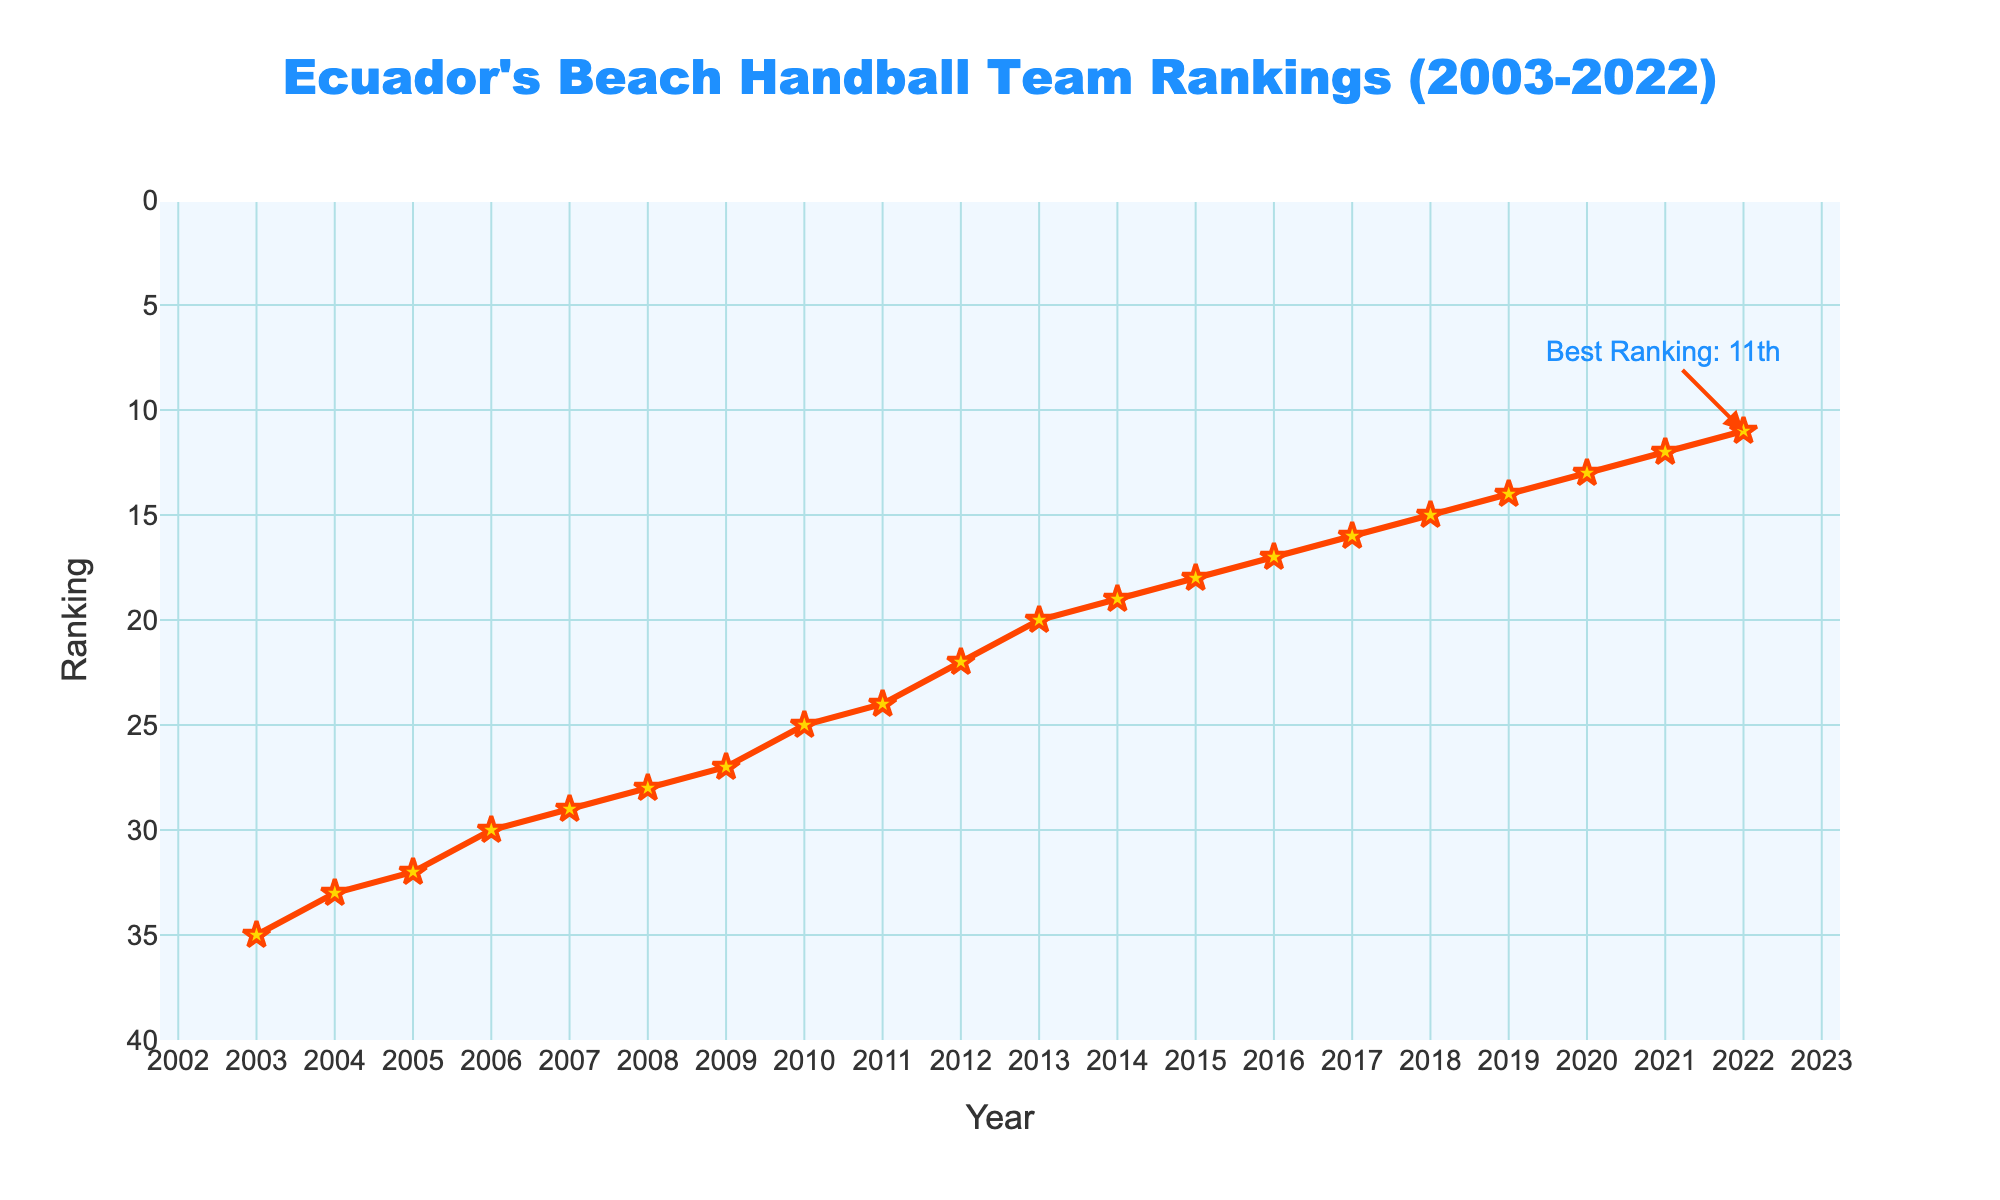What's the trend in Ecuador's beach handball team rankings from 2003 to 2022? The rankings show a steady improvement over the years, starting from 35th place in 2003 and reaching 11th place in 2022.
Answer: Continuous improvement In which year did Ecuador's beach handball team achieve its best ranking? The best ranking is annotated in the figure, indicating that Ecuador reached the 11th position in 2022.
Answer: 2022 How many positions did Ecuador's beach handball team improve from 2003 to 2022? The team improved from the 35th position in 2003 to the 11th position in 2022. The difference is 35 - 11 = 24 positions.
Answer: 24 positions Between which consecutive years did the team's ranking improve the most? To identify the largest improvement, we need to evaluate the yearly differences. The largest improvement occurred between 2009 (27) and 2010 (25), with a difference of 2 positions.
Answer: 2009 and 2010 What is the average ranking of Ecuador's beach handball team from 2003 to 2022? Sum all the rankings from 2003 to 2022: 35 + 33 + 32 + 30 + 29 + 28 + 27 + 25 + 24 + 22 + 20 + 19 + 18 + 17 + 16 + 15 + 14 + 13 + 12 + 11 = 430. There are 20 years, so the average is 430 / 20 = 21.5.
Answer: 21.5 Which year saw the highest ranking for Ecuador's beach handball team before 2020? Before 2020, the best ranking achieved by Ecuador's team was in 2019 with a ranking of 14th place.
Answer: 2019 What is the ranking range of Ecuador's beach handball team from 2003 to 2022? The range is calculated by subtracting the lowest ranking from the highest ranking. The lowest is 11 in 2022, and the highest is 35 in 2003. So the range is 35 - 11 = 24.
Answer: 24 How many years did it take for Ecuador's beach handball team to break into the top 20? The team broke into the top 20 for the first time in 2013, starting from 2003. So it took 2013 - 2003 = 10 years.
Answer: 10 years Which years did the team maintain or improve their ranking for three consecutive years? From 2011 to 2013, the rankings were 24, 22, and 20, showing continuous improvement. Similarly, from 2019 to 2021, the rankings were 14, 13, and 12.
Answer: 2011-2013 and 2019-2021 